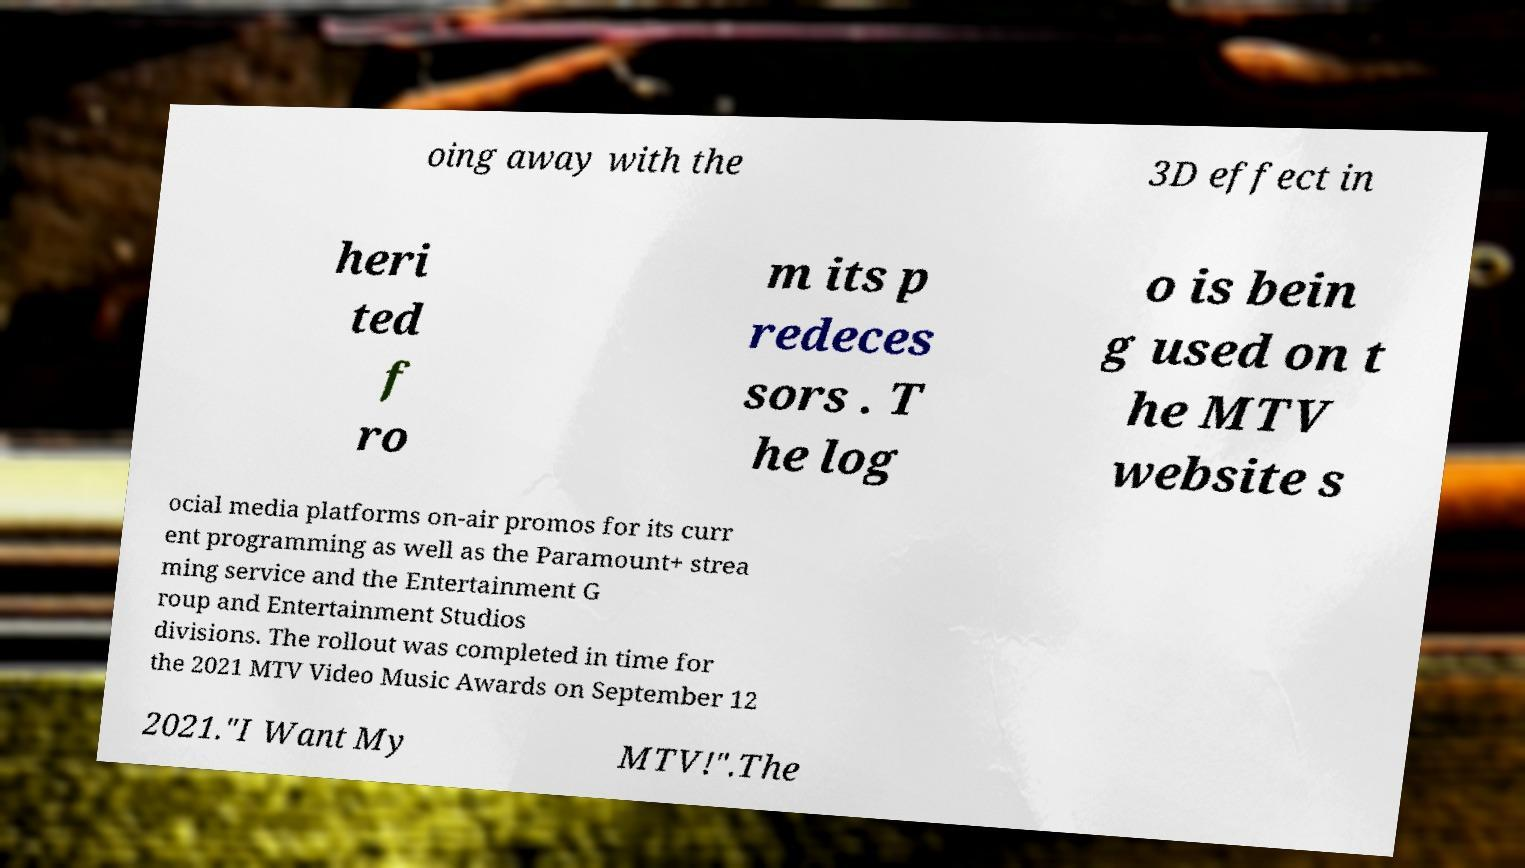There's text embedded in this image that I need extracted. Can you transcribe it verbatim? oing away with the 3D effect in heri ted f ro m its p redeces sors . T he log o is bein g used on t he MTV website s ocial media platforms on-air promos for its curr ent programming as well as the Paramount+ strea ming service and the Entertainment G roup and Entertainment Studios divisions. The rollout was completed in time for the 2021 MTV Video Music Awards on September 12 2021."I Want My MTV!".The 